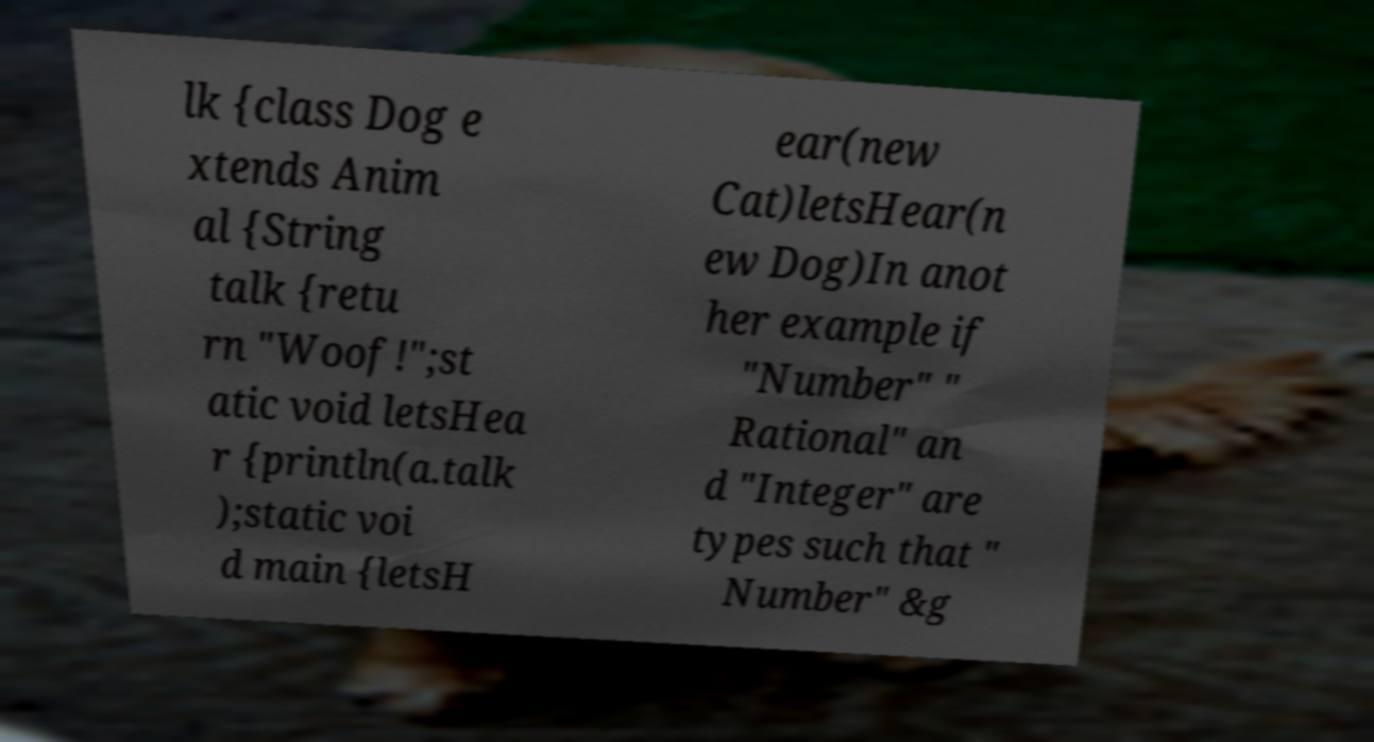I need the written content from this picture converted into text. Can you do that? lk {class Dog e xtends Anim al {String talk {retu rn "Woof!";st atic void letsHea r {println(a.talk );static voi d main {letsH ear(new Cat)letsHear(n ew Dog)In anot her example if "Number" " Rational" an d "Integer" are types such that " Number" &g 